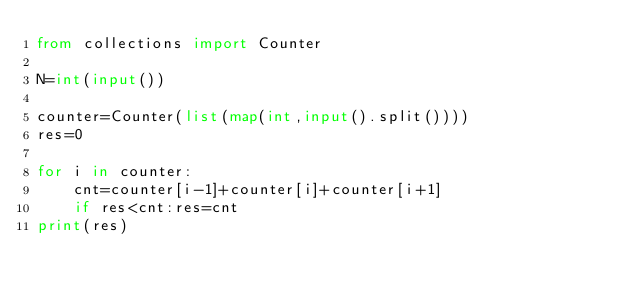<code> <loc_0><loc_0><loc_500><loc_500><_Python_>from collections import Counter

N=int(input())

counter=Counter(list(map(int,input().split())))
res=0

for i in counter:
    cnt=counter[i-1]+counter[i]+counter[i+1]
    if res<cnt:res=cnt
print(res)</code> 